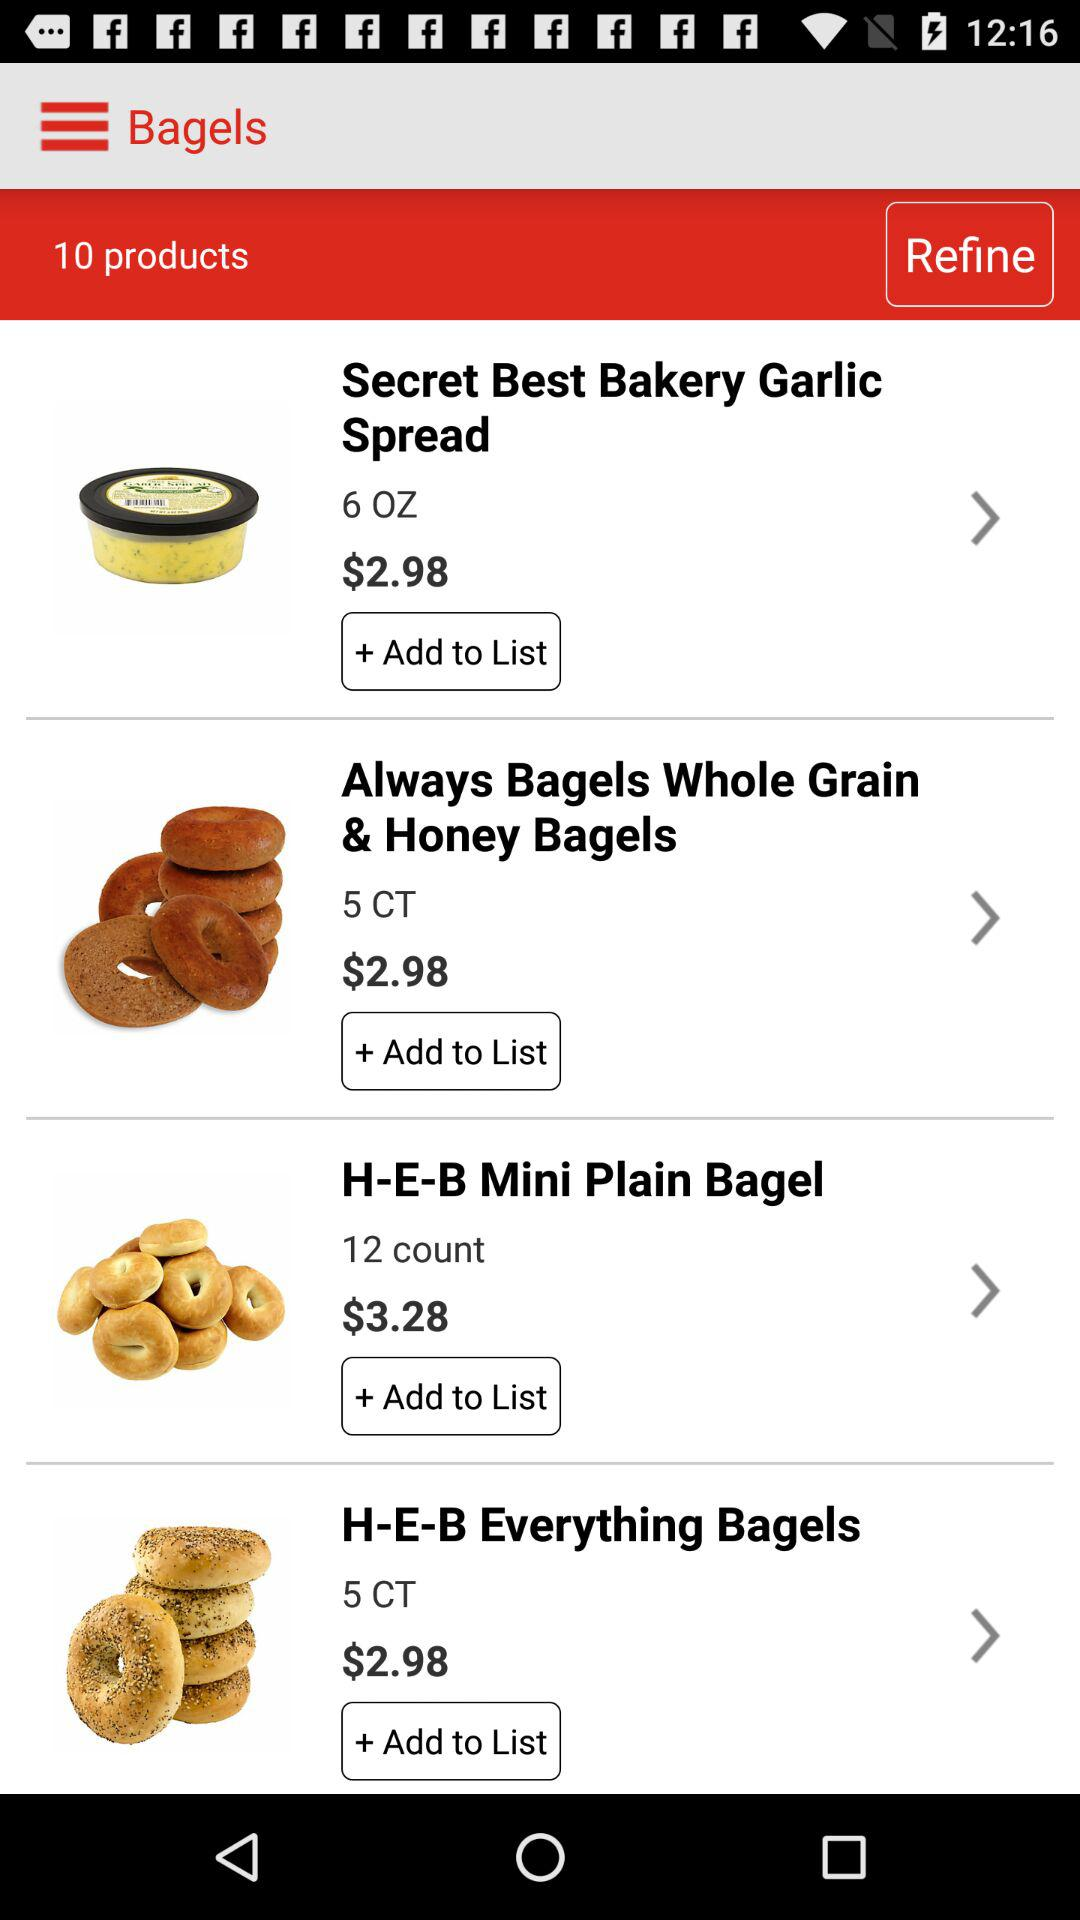What is the quantity of H-E-B Mini Plain Bagel? The quantity is 12. 